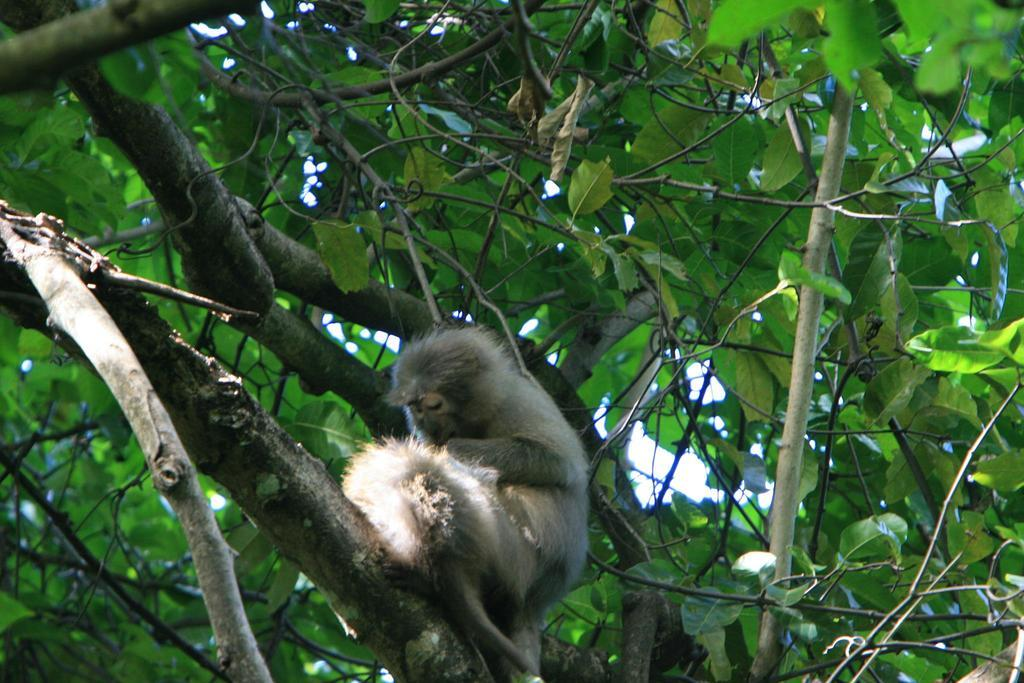What animal is present in the image? There is a monkey in the image. Where is the monkey located? The monkey is on a tree. What type of vegetation is surrounding the monkey? There are green leaves around the monkey. How many giants are visible in the image? There are no giants present in the image. What is the grandfather doing in the image? There is no grandfather present in the image. 